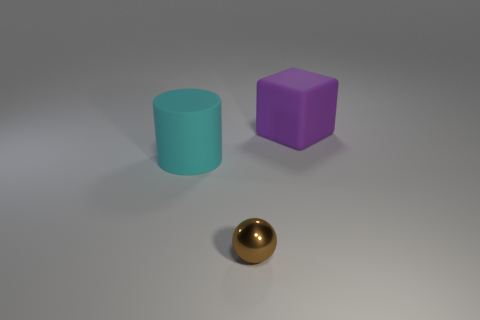Add 1 small rubber cylinders. How many objects exist? 4 Subtract all cylinders. How many objects are left? 2 Add 3 purple cubes. How many purple cubes are left? 4 Add 3 big matte things. How many big matte things exist? 5 Subtract 0 green cylinders. How many objects are left? 3 Subtract all green shiny cylinders. Subtract all large cyan matte things. How many objects are left? 2 